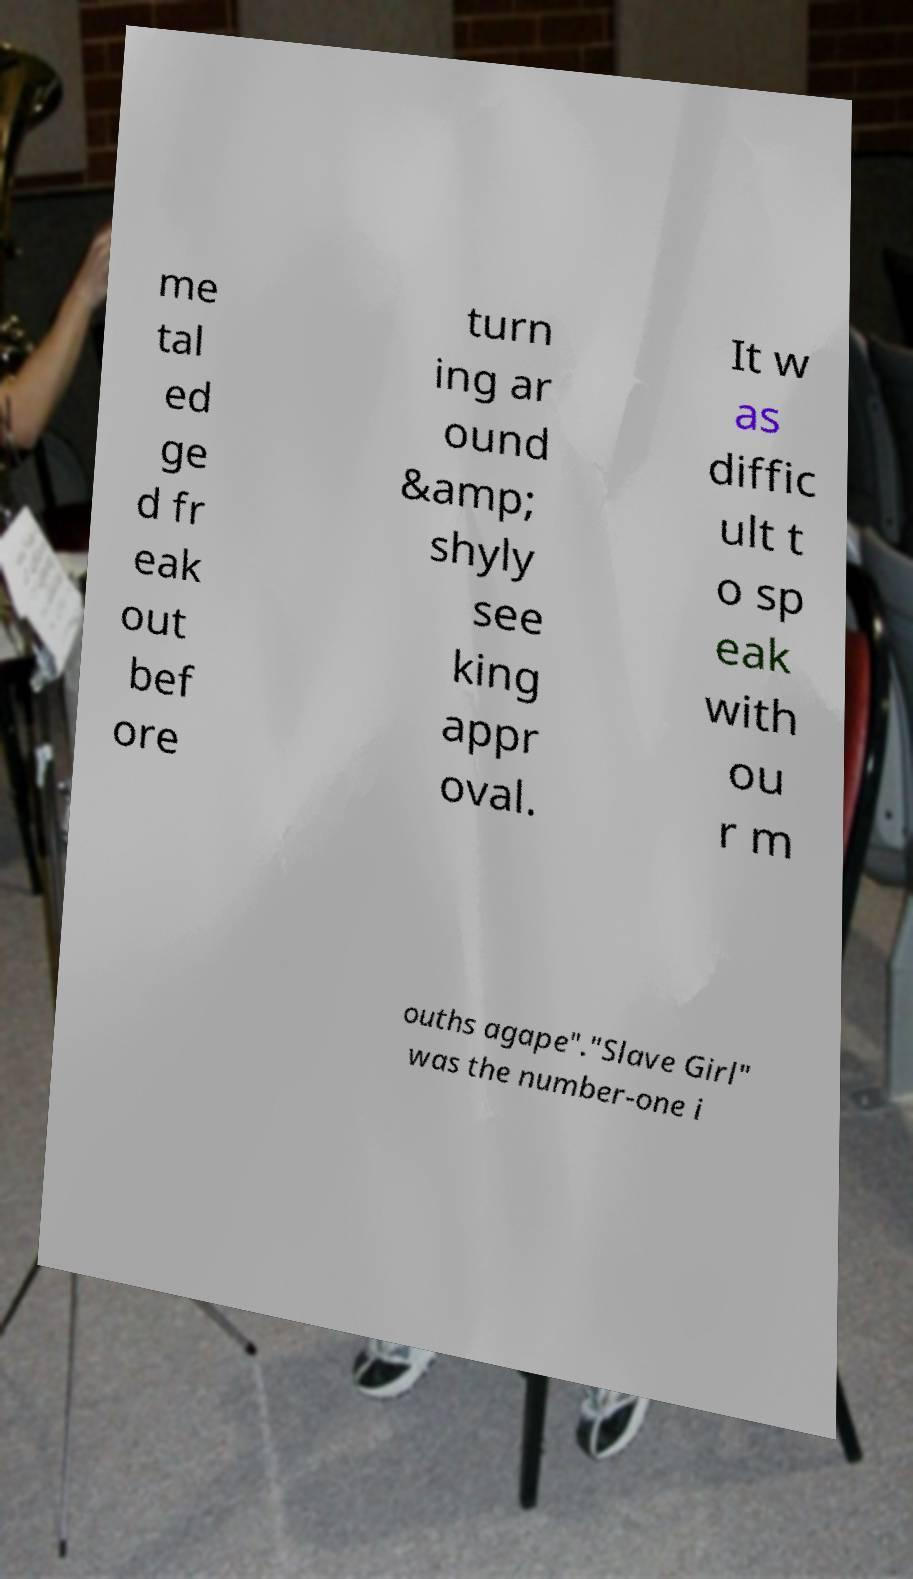Can you accurately transcribe the text from the provided image for me? me tal ed ge d fr eak out bef ore turn ing ar ound &amp; shyly see king appr oval. It w as diffic ult t o sp eak with ou r m ouths agape"."Slave Girl" was the number-one i 